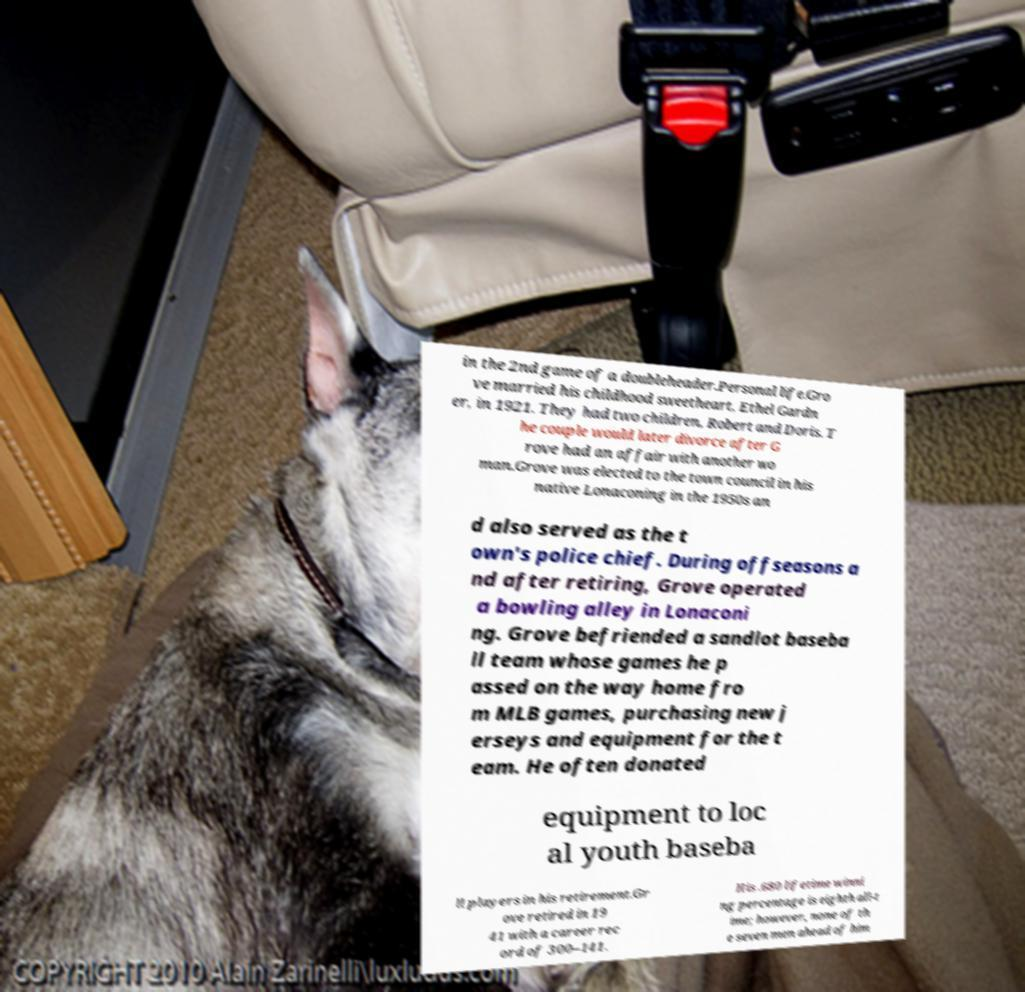Please read and relay the text visible in this image. What does it say? in the 2nd game of a doubleheader.Personal life.Gro ve married his childhood sweetheart, Ethel Gardn er, in 1921. They had two children, Robert and Doris. T he couple would later divorce after G rove had an affair with another wo man.Grove was elected to the town council in his native Lonaconing in the 1950s an d also served as the t own's police chief. During offseasons a nd after retiring, Grove operated a bowling alley in Lonaconi ng. Grove befriended a sandlot baseba ll team whose games he p assed on the way home fro m MLB games, purchasing new j erseys and equipment for the t eam. He often donated equipment to loc al youth baseba ll players in his retirement.Gr ove retired in 19 41 with a career rec ord of 300–141. His .680 lifetime winni ng percentage is eighth all-t ime; however, none of th e seven men ahead of him 